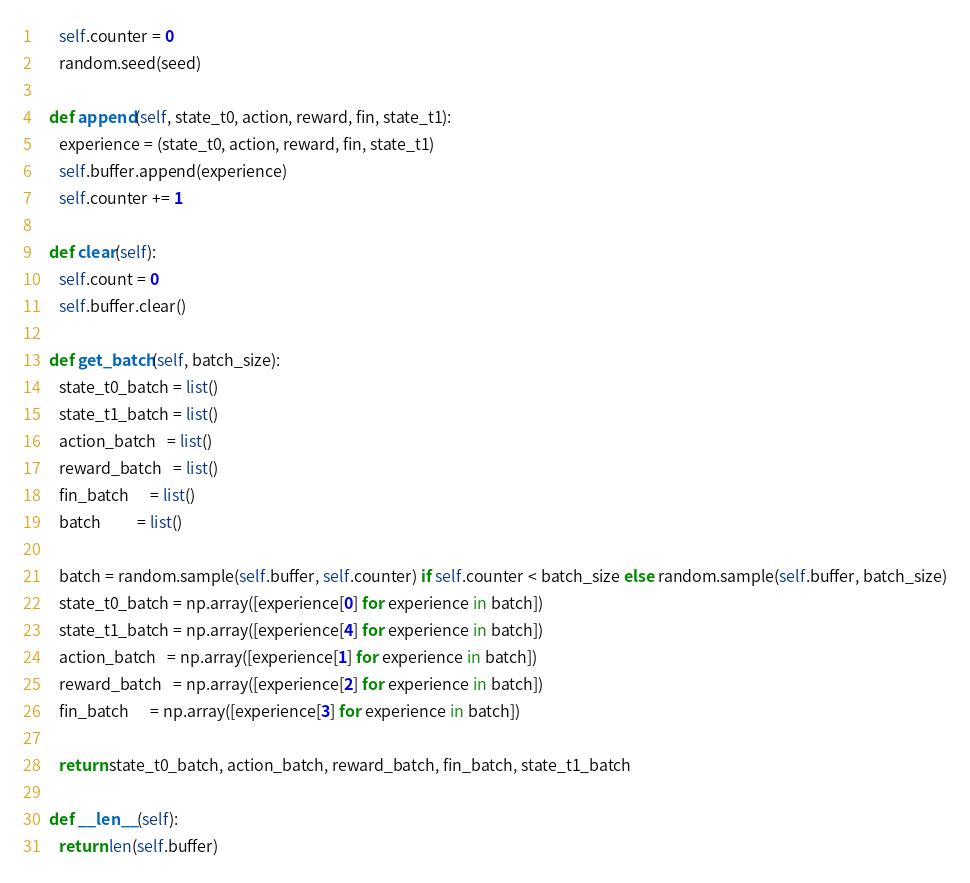Convert code to text. <code><loc_0><loc_0><loc_500><loc_500><_Python_>      self.counter = 0
      random.seed(seed)

   def append(self, state_t0, action, reward, fin, state_t1):
      experience = (state_t0, action, reward, fin, state_t1)
      self.buffer.append(experience)
      self.counter += 1

   def clear(self):
      self.count = 0
      self.buffer.clear()

   def get_batch(self, batch_size):
      state_t0_batch = list()
      state_t1_batch = list()
      action_batch   = list()
      reward_batch   = list()
      fin_batch      = list()
      batch          = list()

      batch = random.sample(self.buffer, self.counter) if self.counter < batch_size else random.sample(self.buffer, batch_size)
      state_t0_batch = np.array([experience[0] for experience in batch])
      state_t1_batch = np.array([experience[4] for experience in batch])
      action_batch   = np.array([experience[1] for experience in batch])
      reward_batch   = np.array([experience[2] for experience in batch])
      fin_batch      = np.array([experience[3] for experience in batch])

      return state_t0_batch, action_batch, reward_batch, fin_batch, state_t1_batch
   
   def __len__(self):
      return len(self.buffer)</code> 